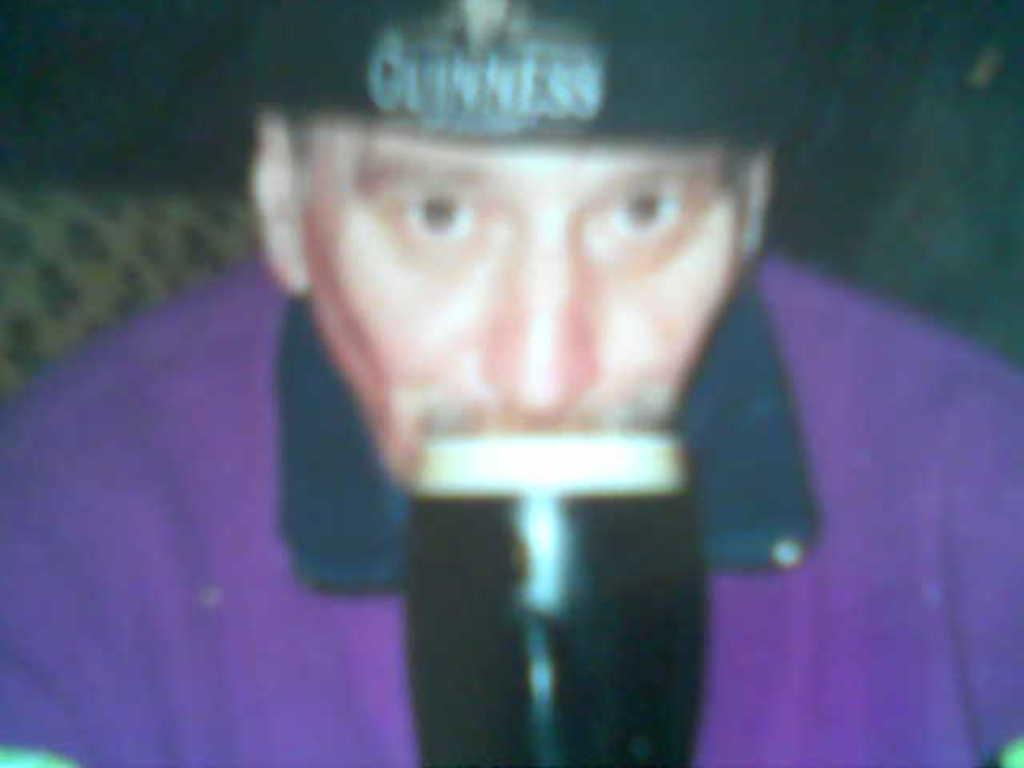Who is present in the image? There is a man in the image. What is the man wearing on his head? The man is wearing a cap. What can be seen in front of the man? There is an object in front of the man. How would you describe the background of the image? The background of the image is dark. What type of cave can be seen in the background of the image? There is no cave present in the image; the background is dark, but no specific features are mentioned. 